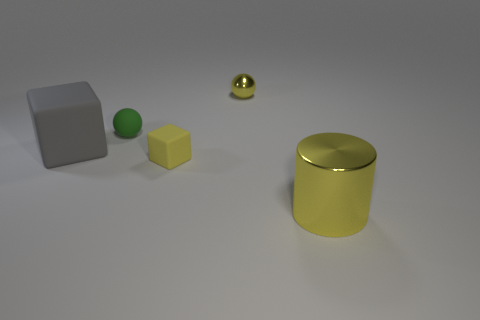Subtract all gray cubes. How many cubes are left? 1 Add 1 big cylinders. How many objects exist? 6 Subtract all spheres. How many objects are left? 3 Subtract all green spheres. Subtract all green cylinders. How many spheres are left? 1 Subtract all purple balls. How many blue cubes are left? 0 Subtract all cubes. Subtract all yellow blocks. How many objects are left? 2 Add 3 matte objects. How many matte objects are left? 6 Add 4 small cubes. How many small cubes exist? 5 Subtract 0 gray cylinders. How many objects are left? 5 